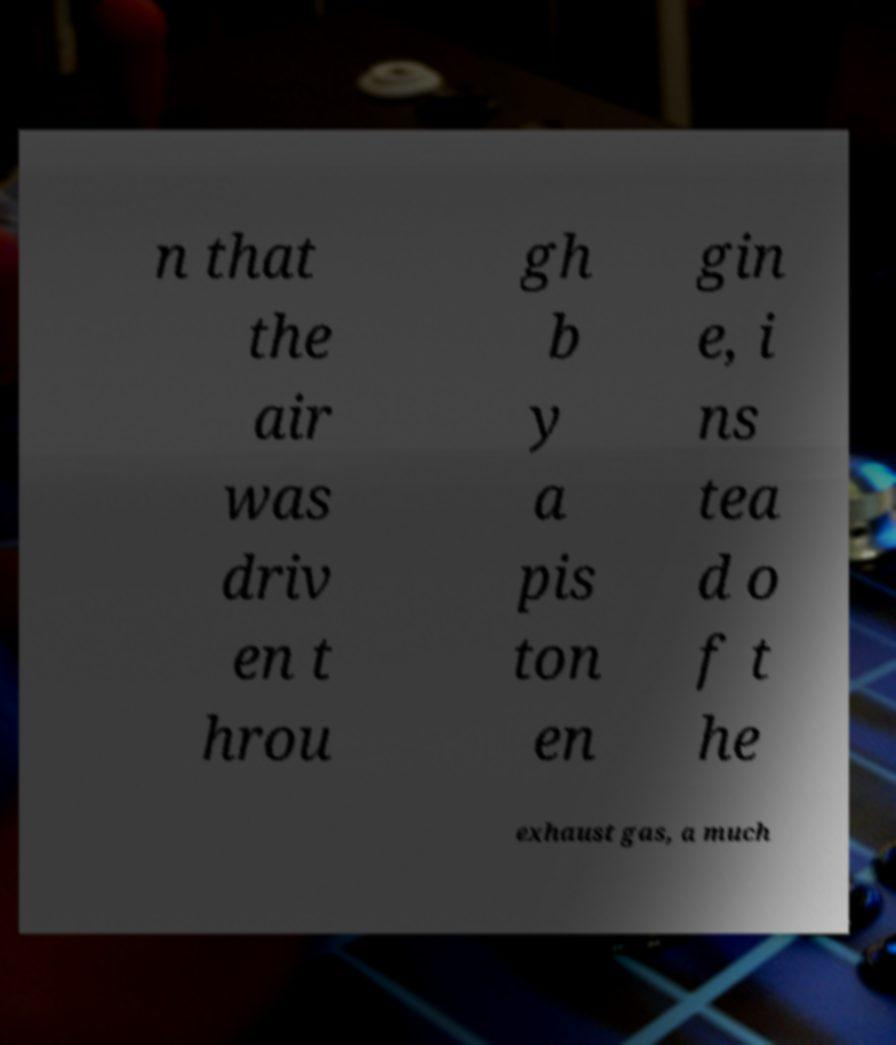Can you accurately transcribe the text from the provided image for me? n that the air was driv en t hrou gh b y a pis ton en gin e, i ns tea d o f t he exhaust gas, a much 